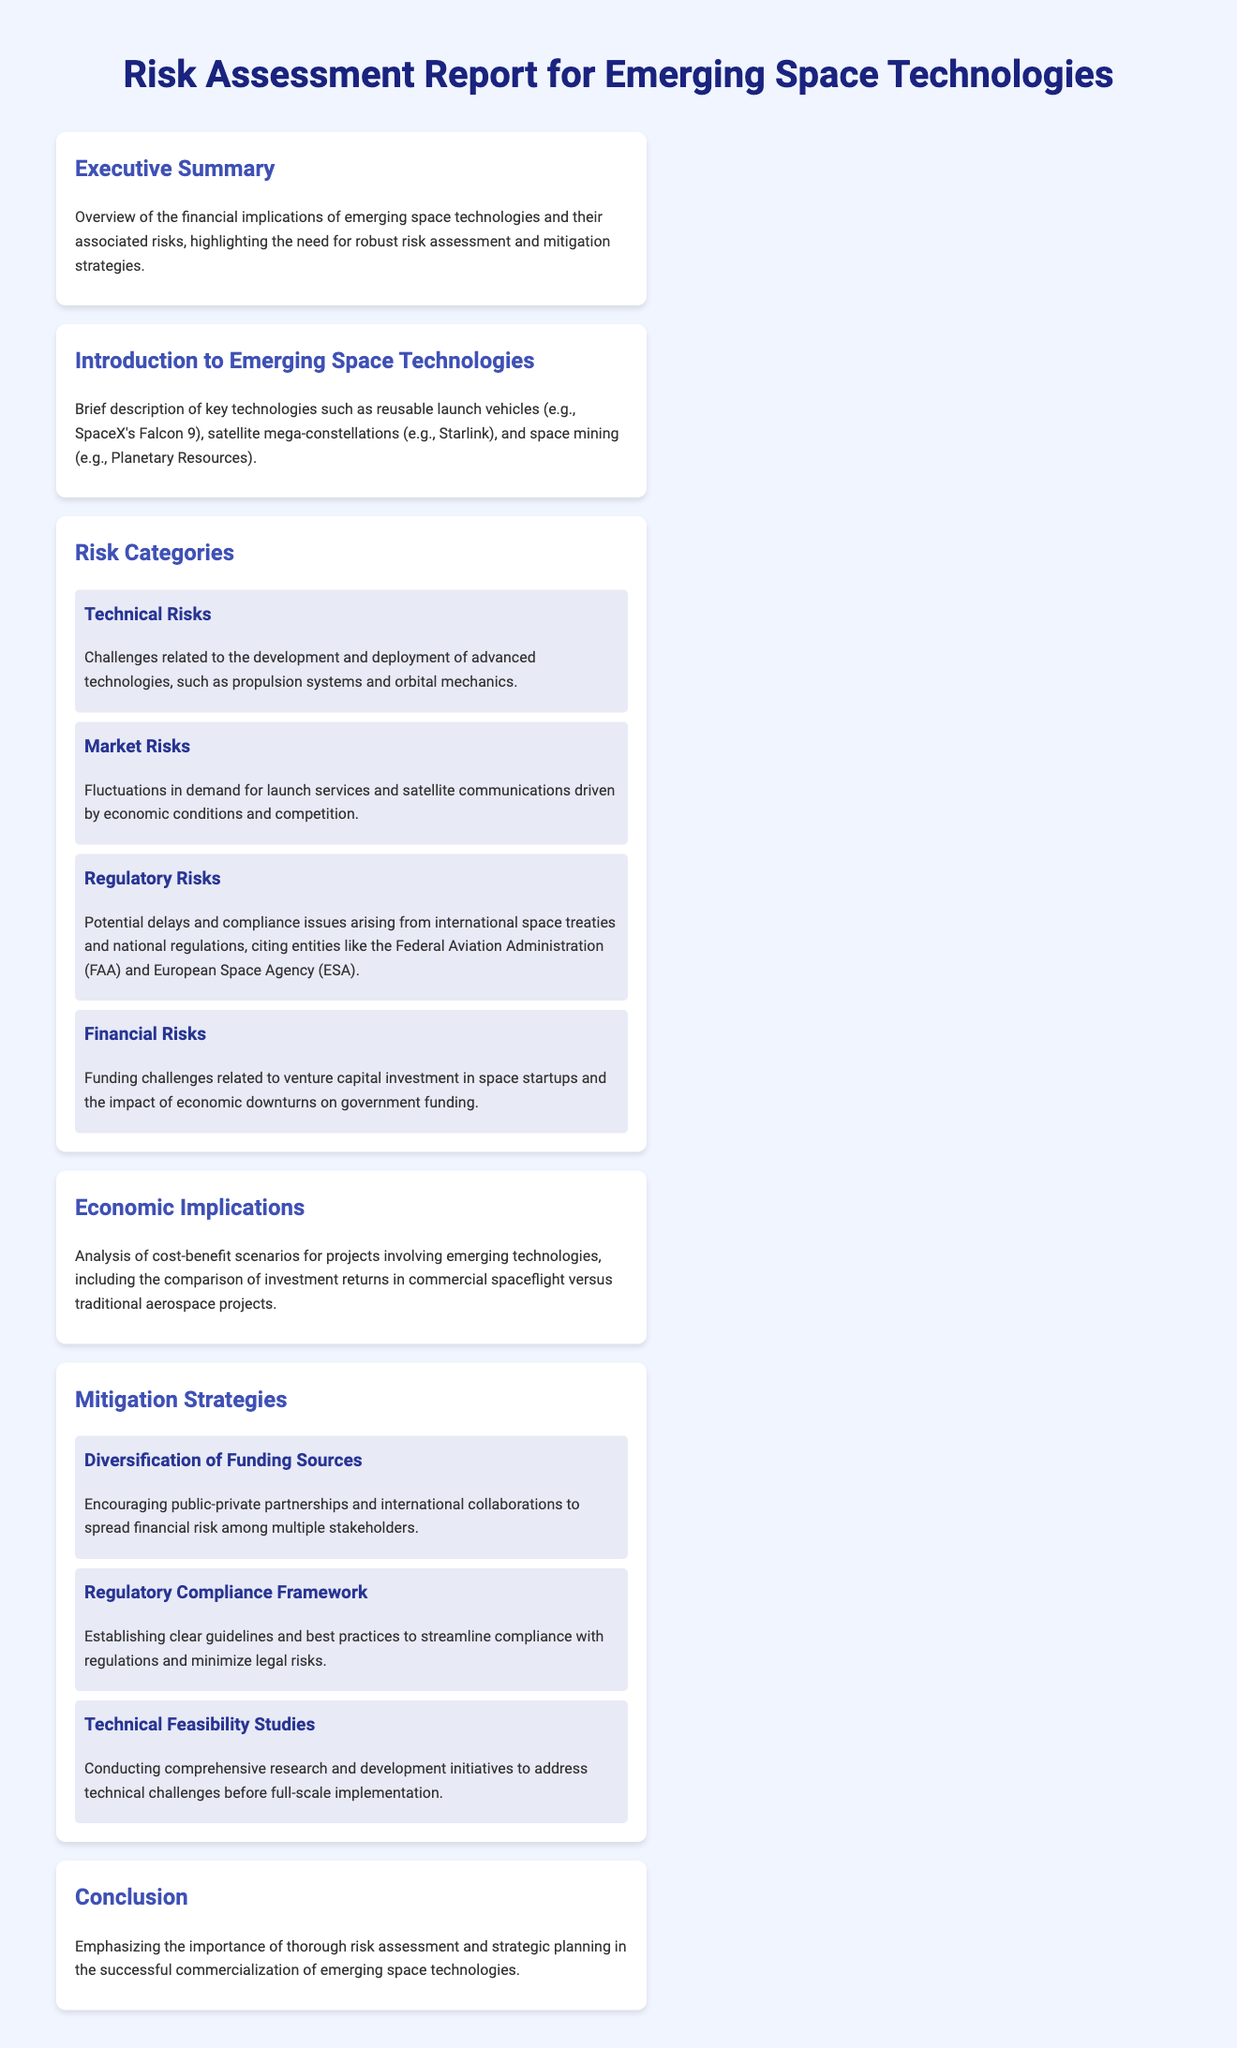What is the title of the report? The title is the first line in the document, which summarizes its purpose.
Answer: Risk Assessment Report for Emerging Space Technologies What are the key technologies mentioned? The key technologies are specified in the introduction section of the document.
Answer: Reusable launch vehicles, satellite mega-constellations, space mining What is a technical risk related to emerging space technologies? Technical risks are categorized in the report, and one such risk is identified.
Answer: Challenges related to propulsion systems What is a mitigation strategy mentioned in the report? The report lists several mitigation strategies that can be employed to manage risks.
Answer: Diversification of Funding Sources Which organization is cited as a regulatory risk entity? An organization is mentioned in the regulatory risks category, indicating potential legal implications.
Answer: Federal Aviation Administration What is the main focus of the Executive Summary? The Executive Summary provides a concise overview of the report's content and emphasis.
Answer: Financial implications and associated risks What type of risks does the report categorize? The report classifies various risks in its risk assessment section.
Answer: Technical, Market, Regulatory, Financial What economic analysis is performed in the report? The Economic Implications section addresses the economic evaluation of projects.
Answer: Cost-benefit scenarios What is the conclusion about risk assessment? The conclusion summarizes the report's main argument regarding risk assessment.
Answer: Importance of thorough risk assessment 